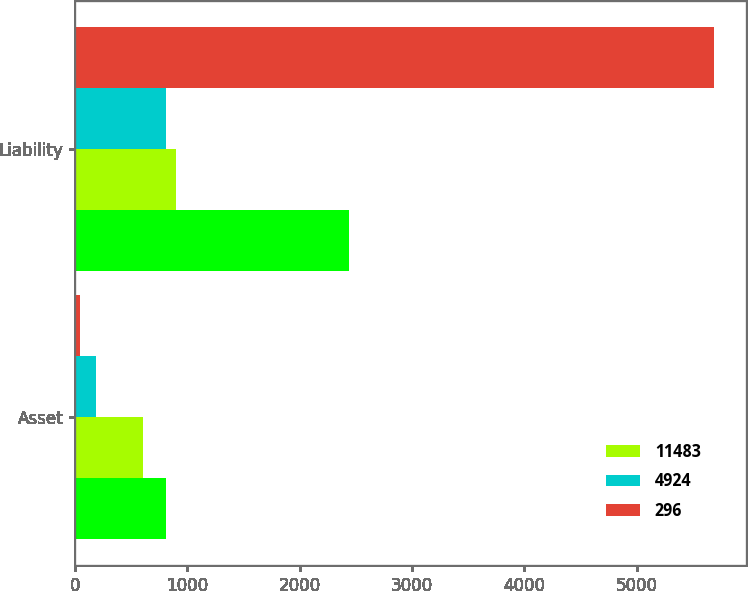Convert chart. <chart><loc_0><loc_0><loc_500><loc_500><stacked_bar_chart><ecel><fcel>Asset<fcel>Liability<nl><fcel>nan<fcel>809<fcel>2436<nl><fcel>11483<fcel>606<fcel>902<nl><fcel>4924<fcel>187<fcel>809<nl><fcel>296<fcel>45<fcel>5686<nl></chart> 